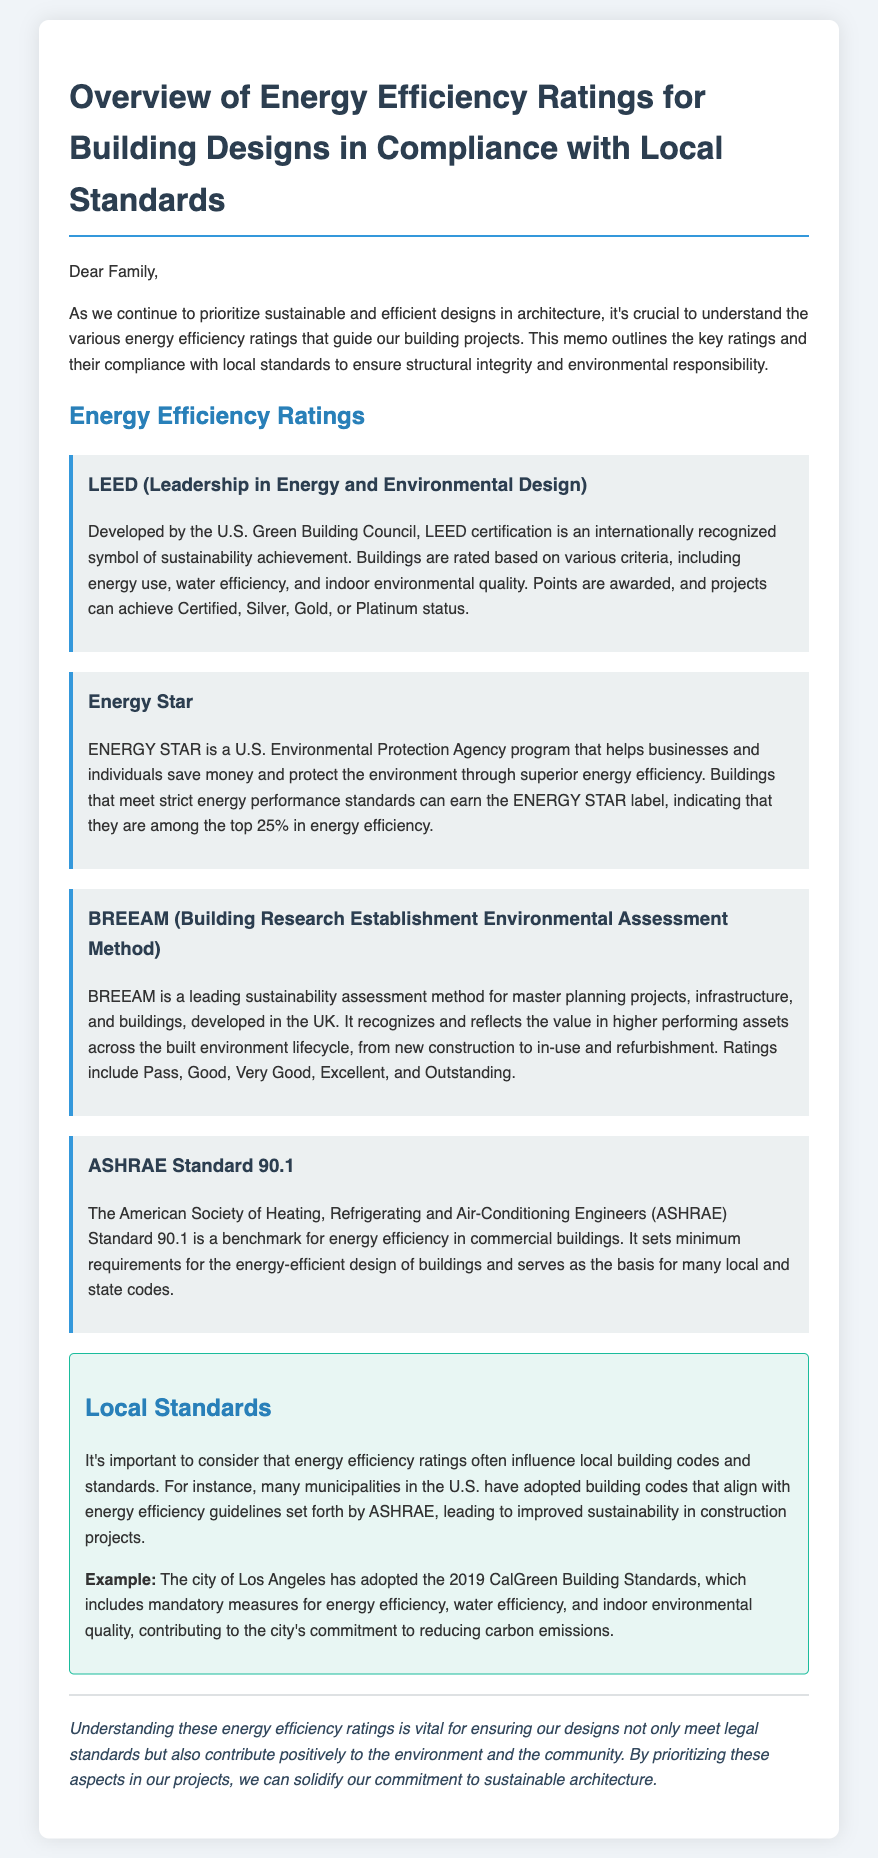What does LEED stand for? LEED is an acronym that represents Leadership in Energy and Environmental Design.
Answer: Leadership in Energy and Environmental Design Who developed the Energy Star program? The Energy Star program was developed by the U.S. Environmental Protection Agency.
Answer: U.S. Environmental Protection Agency What rating does BREEAM use to indicate top performance? BREEAM uses the rating "Outstanding" to indicate top performance.
Answer: Outstanding What is the minimum requirement standard for energy efficiency in commercial buildings? ASHRAE Standard 90.1 sets the minimum requirements for energy efficiency in commercial buildings.
Answer: ASHRAE Standard 90.1 What city adopted the 2019 CalGreen Building Standards? The city of Los Angeles adopted the 2019 CalGreen Building Standards.
Answer: Los Angeles What is the highest status a project can achieve in LEED? The highest status a project can achieve in LEED is Platinum.
Answer: Platinum How many ratings does BREEAM include? BREEAM includes five ratings: Pass, Good, Very Good, Excellent, and Outstanding.
Answer: Five What is the purpose of the memo? The purpose of the memo is to outline key energy efficiency ratings and their compliance with local standards.
Answer: Outline key energy efficiency ratings What is a key benefit of buildings receiving the ENERGY STAR label? A key benefit is that they are among the top 25% in energy efficiency.
Answer: Top 25% in energy efficiency 